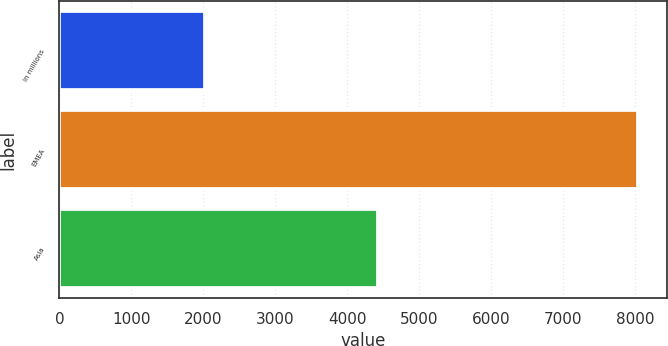Convert chart. <chart><loc_0><loc_0><loc_500><loc_500><bar_chart><fcel>in millions<fcel>EMEA<fcel>Asia<nl><fcel>2016<fcel>8040<fcel>4424<nl></chart> 